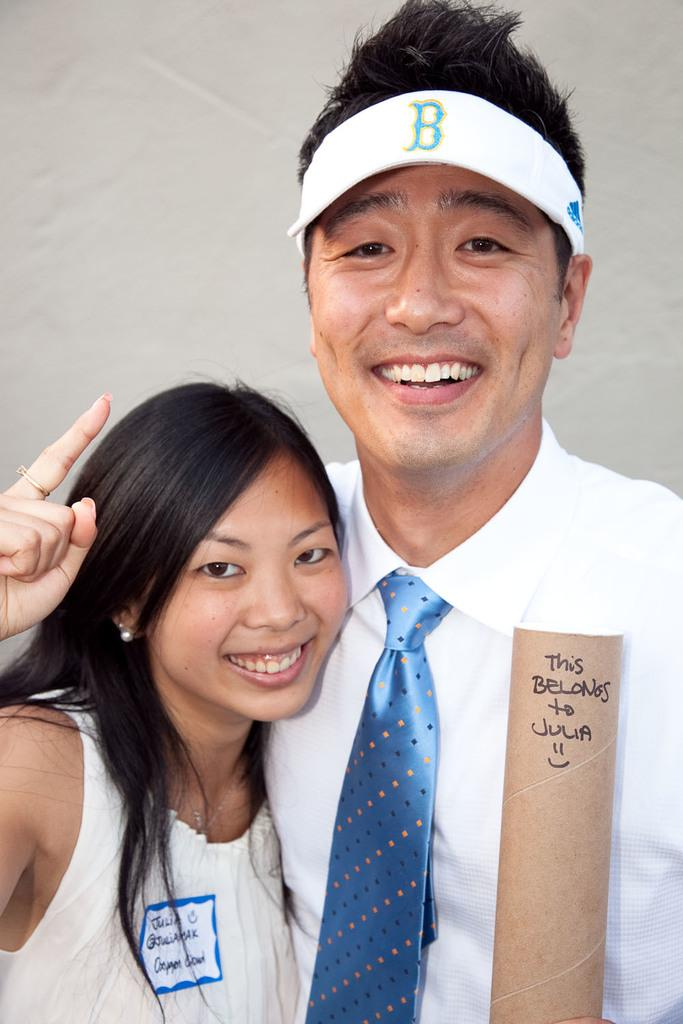What is present in the background of the image? There is a wall in the image. How many people are visible in the image? There are two people standing in the front of the image. What are the people wearing? The two people are wearing white color dresses. What type of stove can be seen in the image? There is no stove present in the image. How many roses are being held by the people in the image? There are no roses visible in the image. 